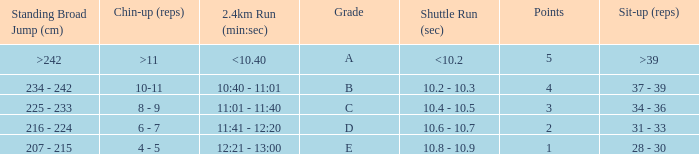Tell me the 2.4km run for points less than 2 12:21 - 13:00. 